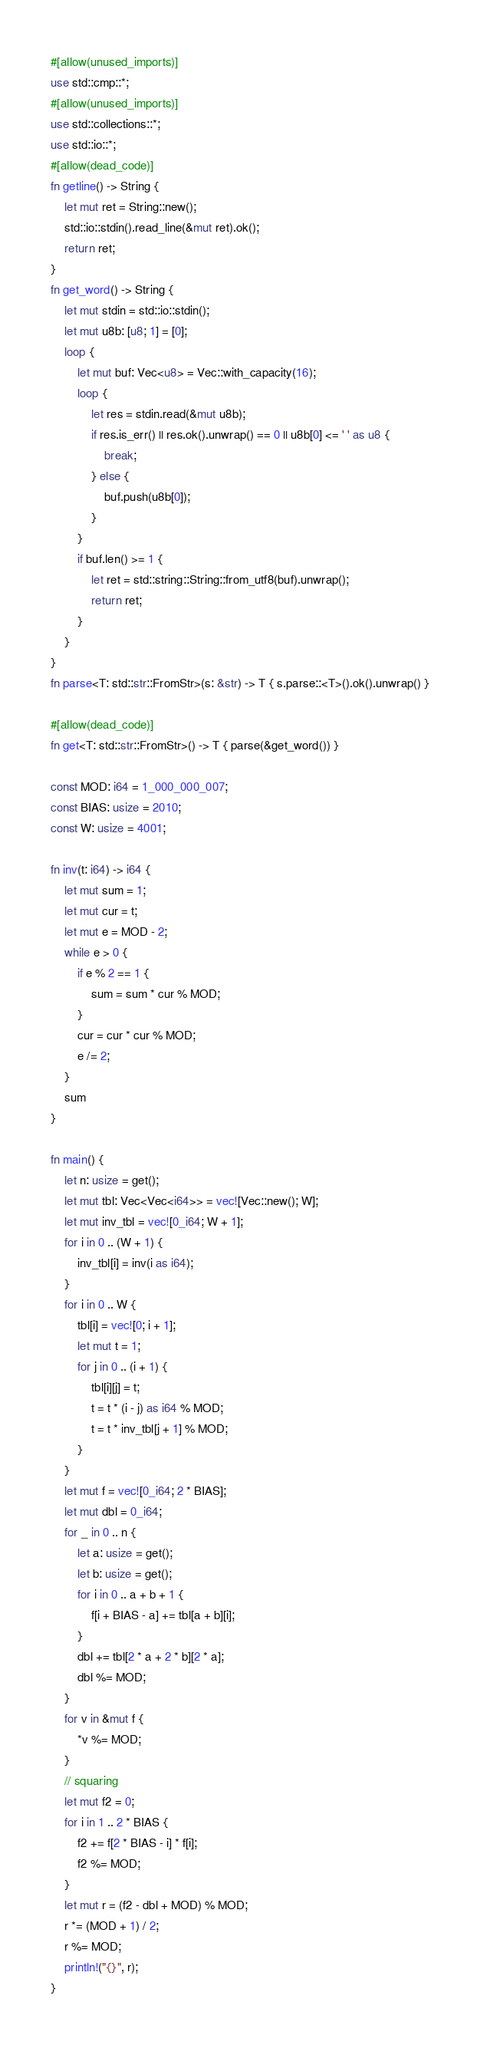Convert code to text. <code><loc_0><loc_0><loc_500><loc_500><_Rust_>#[allow(unused_imports)]
use std::cmp::*;
#[allow(unused_imports)]
use std::collections::*;
use std::io::*;
#[allow(dead_code)]
fn getline() -> String {
    let mut ret = String::new();
    std::io::stdin().read_line(&mut ret).ok();
    return ret;
}
fn get_word() -> String {
    let mut stdin = std::io::stdin();
    let mut u8b: [u8; 1] = [0];
    loop {
        let mut buf: Vec<u8> = Vec::with_capacity(16);
        loop {
            let res = stdin.read(&mut u8b);
            if res.is_err() || res.ok().unwrap() == 0 || u8b[0] <= ' ' as u8 {
                break;
            } else {
                buf.push(u8b[0]);
            }
        }
        if buf.len() >= 1 {
            let ret = std::string::String::from_utf8(buf).unwrap();
            return ret;
        }
    }
}
fn parse<T: std::str::FromStr>(s: &str) -> T { s.parse::<T>().ok().unwrap() }

#[allow(dead_code)]
fn get<T: std::str::FromStr>() -> T { parse(&get_word()) }

const MOD: i64 = 1_000_000_007;
const BIAS: usize = 2010;
const W: usize = 4001;

fn inv(t: i64) -> i64 {
    let mut sum = 1;
    let mut cur = t;
    let mut e = MOD - 2;
    while e > 0 {
        if e % 2 == 1 {
            sum = sum * cur % MOD;
        }
        cur = cur * cur % MOD;
        e /= 2;
    }
    sum
}

fn main() {
    let n: usize = get();
    let mut tbl: Vec<Vec<i64>> = vec![Vec::new(); W];
    let mut inv_tbl = vec![0_i64; W + 1];
    for i in 0 .. (W + 1) {
        inv_tbl[i] = inv(i as i64);
    }
    for i in 0 .. W {
        tbl[i] = vec![0; i + 1];
        let mut t = 1;
        for j in 0 .. (i + 1) {
            tbl[i][j] = t;
            t = t * (i - j) as i64 % MOD;
            t = t * inv_tbl[j + 1] % MOD;
        }
    }
    let mut f = vec![0_i64; 2 * BIAS];
    let mut dbl = 0_i64;
    for _ in 0 .. n {
        let a: usize = get();
        let b: usize = get();
        for i in 0 .. a + b + 1 {
            f[i + BIAS - a] += tbl[a + b][i];
        }
        dbl += tbl[2 * a + 2 * b][2 * a];
        dbl %= MOD;
    }
    for v in &mut f {
        *v %= MOD;
    }
    // squaring
    let mut f2 = 0;
    for i in 1 .. 2 * BIAS {
        f2 += f[2 * BIAS - i] * f[i];
        f2 %= MOD;
    }
    let mut r = (f2 - dbl + MOD) % MOD;
    r *= (MOD + 1) / 2;
    r %= MOD;
    println!("{}", r);
}
</code> 